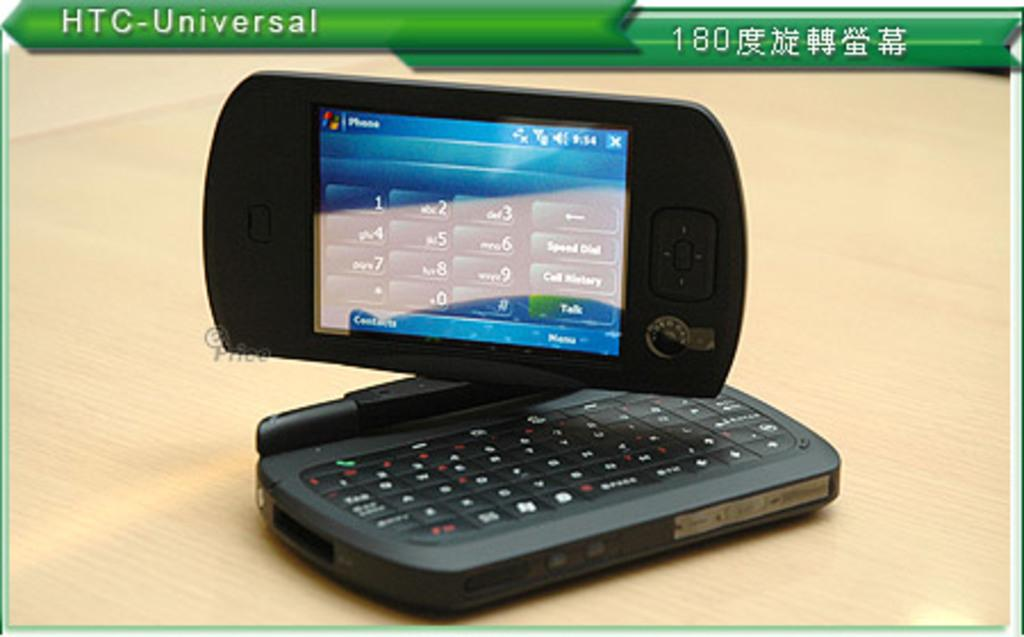<image>
Render a clear and concise summary of the photo. an HTC Universal sign that is above the phone 